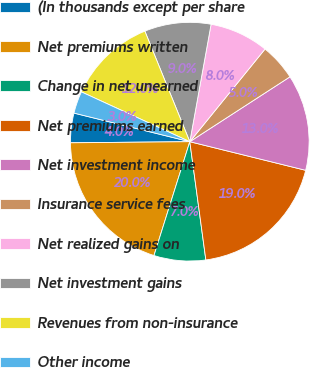Convert chart to OTSL. <chart><loc_0><loc_0><loc_500><loc_500><pie_chart><fcel>(In thousands except per share<fcel>Net premiums written<fcel>Change in net unearned<fcel>Net premiums earned<fcel>Net investment income<fcel>Insurance service fees<fcel>Net realized gains on<fcel>Net investment gains<fcel>Revenues from non-insurance<fcel>Other income<nl><fcel>4.0%<fcel>20.0%<fcel>7.0%<fcel>19.0%<fcel>13.0%<fcel>5.0%<fcel>8.0%<fcel>9.0%<fcel>12.0%<fcel>3.0%<nl></chart> 